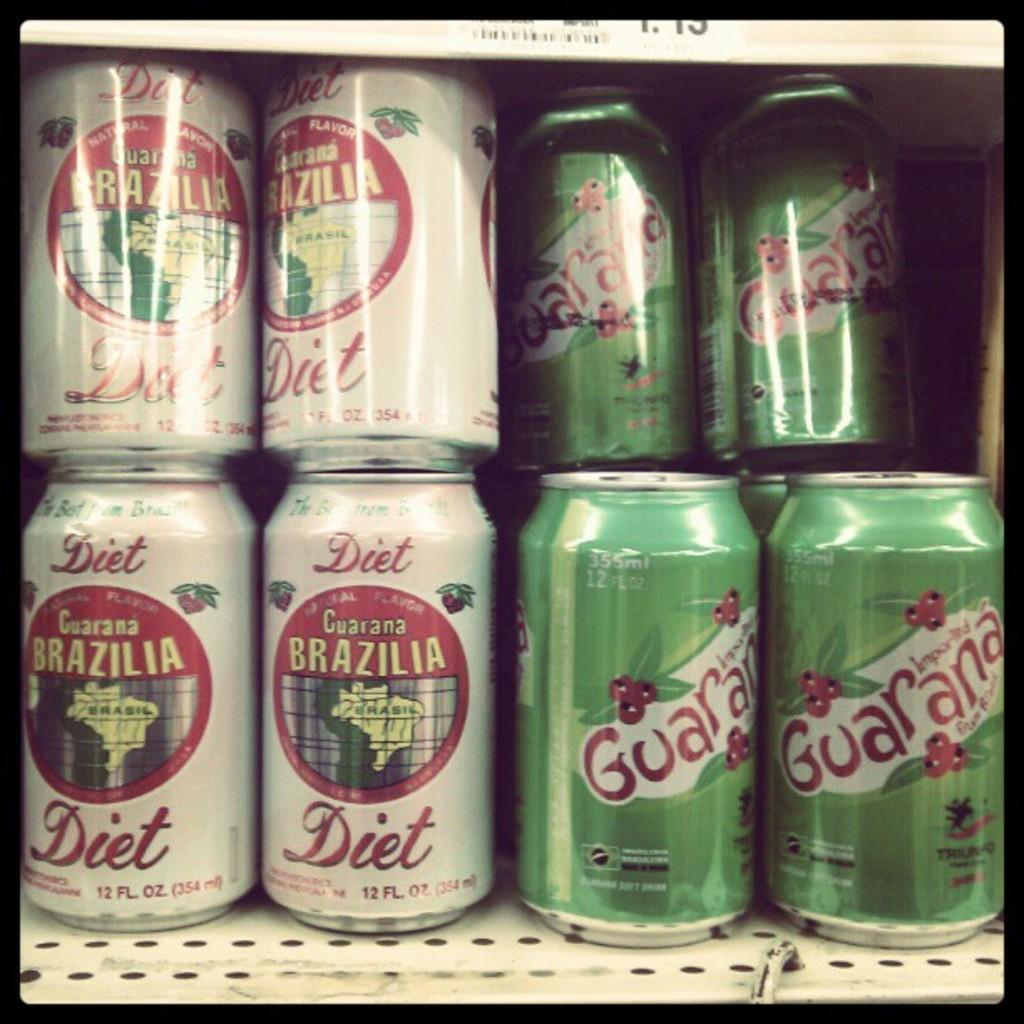Is that a diet drink?
Provide a short and direct response. Yes. 